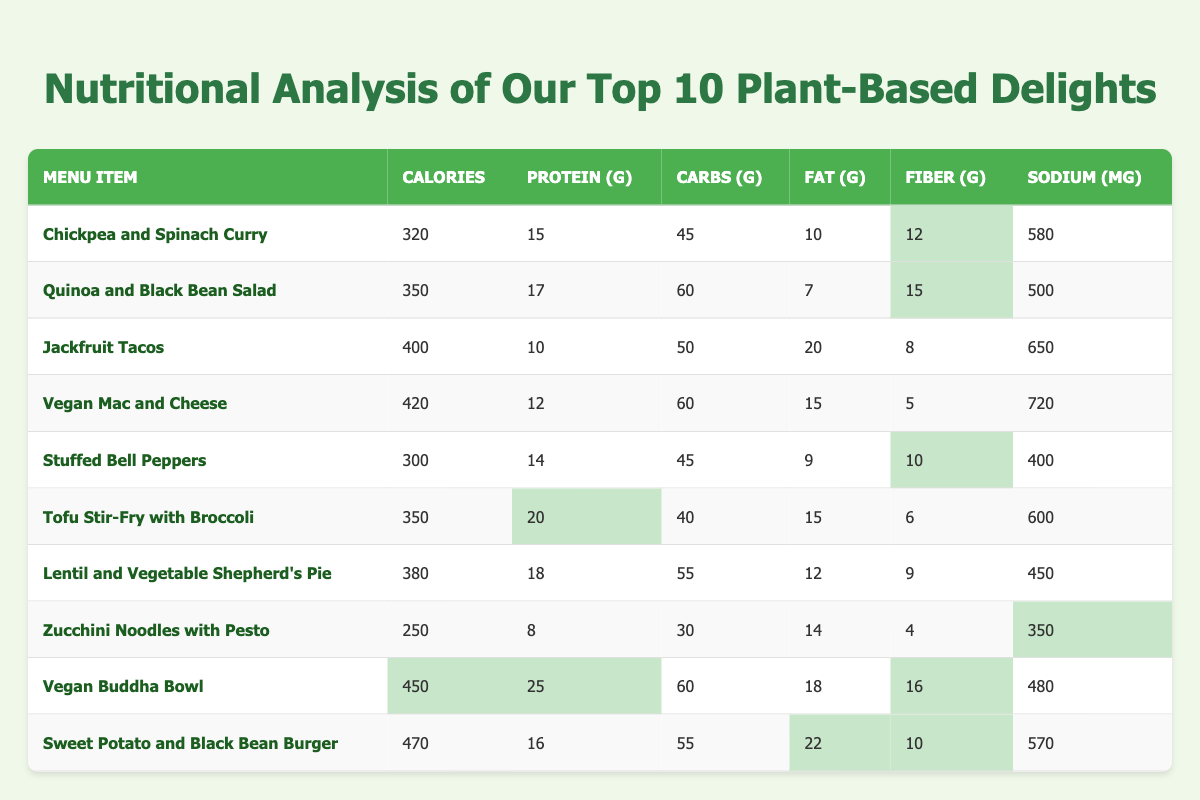What is the highest protein content in a menu item? Looking at the table, the item with the highest protein content is the Vegan Buddha Bowl, which has 25 grams of protein.
Answer: 25 grams Which dish contains the least calories? By scanning the calorie column, the item with the least calories is Zucchini Noodles with Pesto, containing 250 calories.
Answer: 250 calories Is the Chickpea and Spinach Curry higher in fiber than the Jackfruit Tacos? Chickpea and Spinach Curry has 12 grams of fiber, while Jackfruit Tacos have 8 grams of fiber. Yes, it is higher in fiber.
Answer: Yes How much sodium is in the Vegan Mac and Cheese? The table shows that Vegan Mac and Cheese contains 720 milligrams of sodium.
Answer: 720 milligrams What is the average carbohydrate content of the dishes listed? The carbohydrate values are 45, 60, 50, 60, 45, 40, 55, 30, 60, and 55. Adding them up gives 495, and dividing by 10 gives an average of 49.5.
Answer: 49.5 grams Which menu item has the most fat content? By reviewing the fat column, the Sweet Potato and Black Bean Burger has the most fat at 22 grams.
Answer: 22 grams Is the Quinoa and Black Bean Salad healthier than the Jackfruit Tacos based on calories, protein, and fiber? Quinoa and Black Bean Salad has 350 calories, 17 grams of protein, and 15 grams of fiber; Jackfruit Tacos have 400 calories, 10 grams of protein, and 8 grams of fiber. Since it has lower calories, more protein, and more fiber, it is considered healthier.
Answer: Yes What is the difference in calories between the Vegan Buddha Bowl and the Stuffed Bell Peppers? The Vegan Buddha Bowl has 450 calories, and Stuffed Bell Peppers have 300 calories. The difference is 450 - 300 = 150 calories.
Answer: 150 calories How many dishes contain more than 400 calories? The dishes with over 400 calories are Jackfruit Tacos (400), Vegan Mac and Cheese (420), Vegan Buddha Bowl (450), and Sweet Potato and Black Bean Burger (470). Thus, there are 4 total dishes.
Answer: 4 dishes What percentage of fiber does the Tofu Stir-Fry with Broccoli have compared to the Chickpea and Spinach Curry? Tofu Stir-Fry with Broccoli has 6 grams, and Chickpea and Spinach Curry has 12 grams of fiber. The percentage is (6/12) * 100 = 50%, meaning Tofu Stir-Fry has 50% fiber compared to Chickpea.
Answer: 50% 